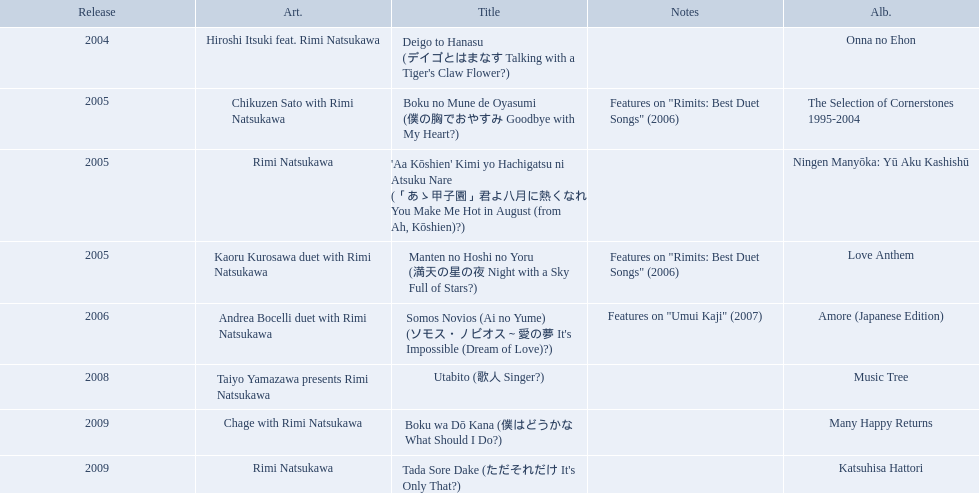What are the names of each album by rimi natsukawa? Onna no Ehon, The Selection of Cornerstones 1995-2004, Ningen Manyōka: Yū Aku Kashishū, Love Anthem, Amore (Japanese Edition), Music Tree, Many Happy Returns, Katsuhisa Hattori. And when were the albums released? 2004, 2005, 2005, 2005, 2006, 2008, 2009, 2009. Was onna no ehon or music tree released most recently? Music Tree. When was onna no ehon released? 2004. When was the selection of cornerstones 1995-2004 released? 2005. What was released in 2008? Music Tree. What are all of the titles? Deigo to Hanasu (デイゴとはまなす Talking with a Tiger's Claw Flower?), Boku no Mune de Oyasumi (僕の胸でおやすみ Goodbye with My Heart?), 'Aa Kōshien' Kimi yo Hachigatsu ni Atsuku Nare (「あゝ甲子園」君よ八月に熱くなれ You Make Me Hot in August (from Ah, Kōshien)?), Manten no Hoshi no Yoru (満天の星の夜 Night with a Sky Full of Stars?), Somos Novios (Ai no Yume) (ソモス・ノビオス～愛の夢 It's Impossible (Dream of Love)?), Utabito (歌人 Singer?), Boku wa Dō Kana (僕はどうかな What Should I Do?), Tada Sore Dake (ただそれだけ It's Only That?). What are their notes? , Features on "Rimits: Best Duet Songs" (2006), , Features on "Rimits: Best Duet Songs" (2006), Features on "Umui Kaji" (2007), , , . Which title shares its notes with manten no hoshi no yoru (man tian noxing noye night with a sky full of stars?)? Boku no Mune de Oyasumi (僕の胸でおやすみ Goodbye with My Heart?). What are the notes for sky full of stars? Features on "Rimits: Best Duet Songs" (2006). What other song features this same note? Boku no Mune de Oyasumi (僕の胸でおやすみ Goodbye with My Heart?). 